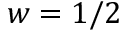Convert formula to latex. <formula><loc_0><loc_0><loc_500><loc_500>w = 1 / 2</formula> 